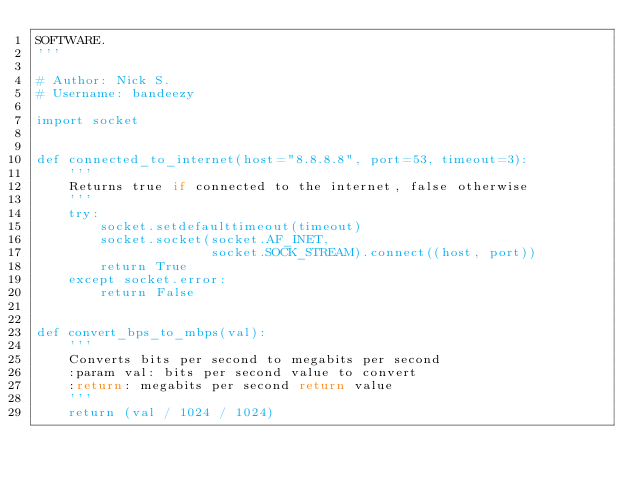Convert code to text. <code><loc_0><loc_0><loc_500><loc_500><_Python_>SOFTWARE.
'''

# Author: Nick S.
# Username: bandeezy

import socket


def connected_to_internet(host="8.8.8.8", port=53, timeout=3):
    '''
    Returns true if connected to the internet, false otherwise
    '''
    try:
        socket.setdefaulttimeout(timeout)
        socket.socket(socket.AF_INET,
                      socket.SOCK_STREAM).connect((host, port))
        return True
    except socket.error:
        return False


def convert_bps_to_mbps(val):
    '''
    Converts bits per second to megabits per second
    :param val: bits per second value to convert
    :return: megabits per second return value
    '''
    return (val / 1024 / 1024)
</code> 